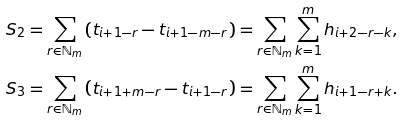<formula> <loc_0><loc_0><loc_500><loc_500>S _ { 2 } & = \sum _ { r \in \mathbb { N } _ { m } } \left ( t _ { i + 1 - r } - t _ { i + 1 - m - r } \right ) = \sum _ { r \in \mathbb { N } _ { m } } \sum _ { k = 1 } ^ { m } h _ { i + 2 - r - k } , \\ S _ { 3 } & = \sum _ { r \in \mathbb { N } _ { m } } \left ( t _ { i + 1 + m - r } - t _ { i + 1 - r } \right ) = \sum _ { r \in \mathbb { N } _ { m } } \sum _ { k = 1 } ^ { m } h _ { i + 1 - r + k } .</formula> 